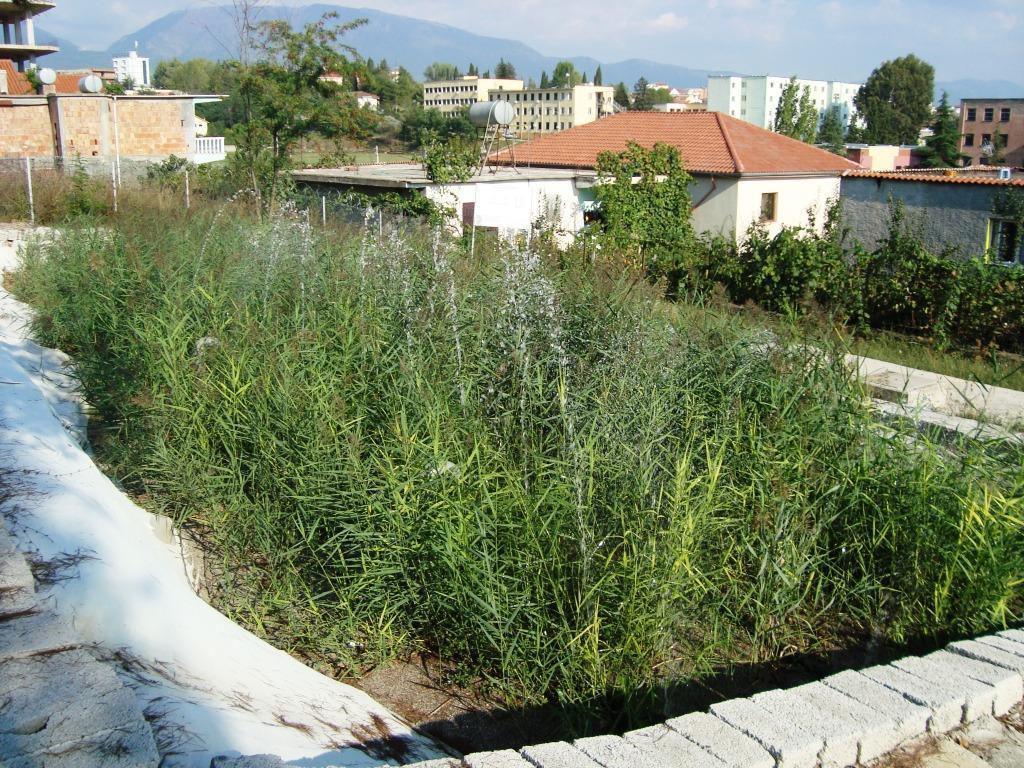What type of vegetation can be seen in the image? There are plants and trees in the image. What material is used for the structures in the image? There are bricks in the image. What can be seen in the background of the image? In the background of the image, there are buildings and hills. What type of secretary can be seen working in the image? There is no secretary present in the image. How does the dust affect the visibility of the plants in the image? There is no dust present in the image, so it does not affect the visibility of the plants. 